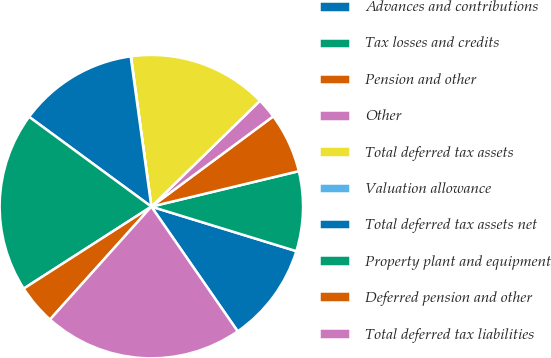Convert chart. <chart><loc_0><loc_0><loc_500><loc_500><pie_chart><fcel>Advances and contributions<fcel>Tax losses and credits<fcel>Pension and other<fcel>Other<fcel>Total deferred tax assets<fcel>Valuation allowance<fcel>Total deferred tax assets net<fcel>Property plant and equipment<fcel>Deferred pension and other<fcel>Total deferred tax liabilities<nl><fcel>10.62%<fcel>8.5%<fcel>6.39%<fcel>2.15%<fcel>14.85%<fcel>0.03%<fcel>12.74%<fcel>19.17%<fcel>4.27%<fcel>21.28%<nl></chart> 